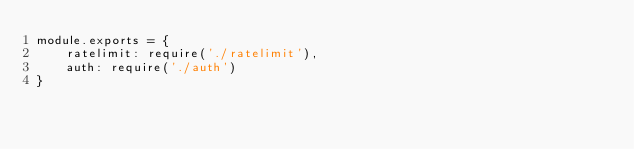Convert code to text. <code><loc_0><loc_0><loc_500><loc_500><_JavaScript_>module.exports = {
    ratelimit: require('./ratelimit'),
    auth: require('./auth')
}</code> 